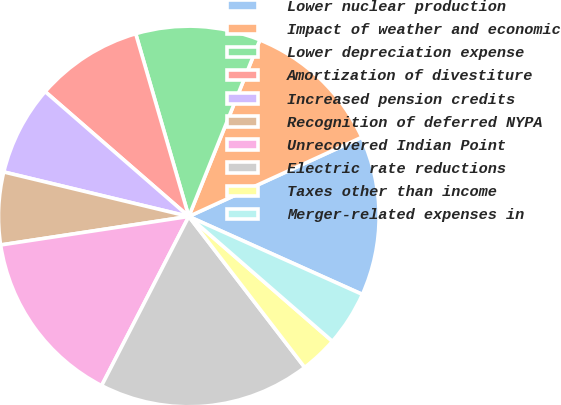Convert chart. <chart><loc_0><loc_0><loc_500><loc_500><pie_chart><fcel>Lower nuclear production<fcel>Impact of weather and economic<fcel>Lower depreciation expense<fcel>Amortization of divestiture<fcel>Increased pension credits<fcel>Recognition of deferred NYPA<fcel>Unrecovered Indian Point<fcel>Electric rate reductions<fcel>Taxes other than income<fcel>Merger-related expenses in<nl><fcel>13.55%<fcel>12.07%<fcel>10.59%<fcel>9.11%<fcel>7.63%<fcel>6.15%<fcel>15.03%<fcel>17.99%<fcel>3.19%<fcel>4.67%<nl></chart> 